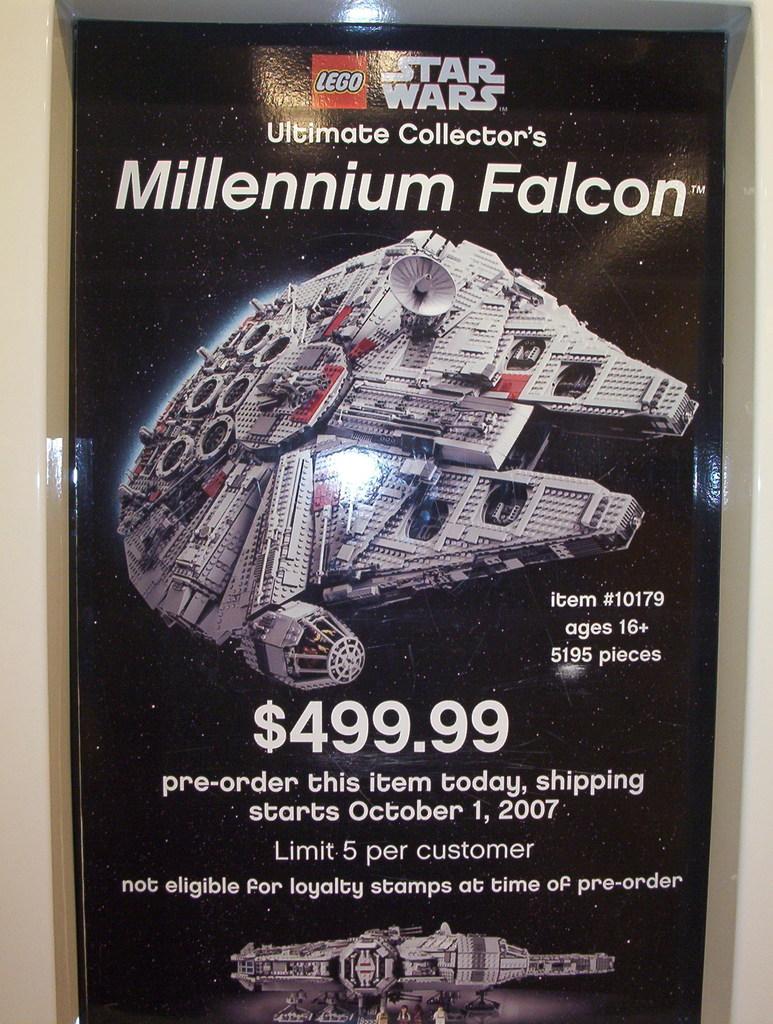When does shipping start?
Keep it short and to the point. October 1, 2007. 